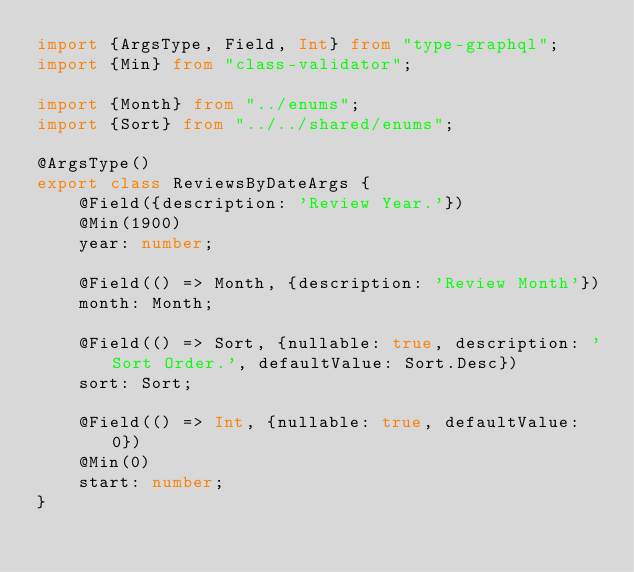Convert code to text. <code><loc_0><loc_0><loc_500><loc_500><_TypeScript_>import {ArgsType, Field, Int} from "type-graphql";
import {Min} from "class-validator";

import {Month} from "../enums";
import {Sort} from "../../shared/enums";

@ArgsType()
export class ReviewsByDateArgs {
    @Field({description: 'Review Year.'})
    @Min(1900)
    year: number;

    @Field(() => Month, {description: 'Review Month'})
    month: Month;

    @Field(() => Sort, {nullable: true, description: 'Sort Order.', defaultValue: Sort.Desc})
    sort: Sort;

    @Field(() => Int, {nullable: true, defaultValue: 0})
    @Min(0)
    start: number;
}
</code> 